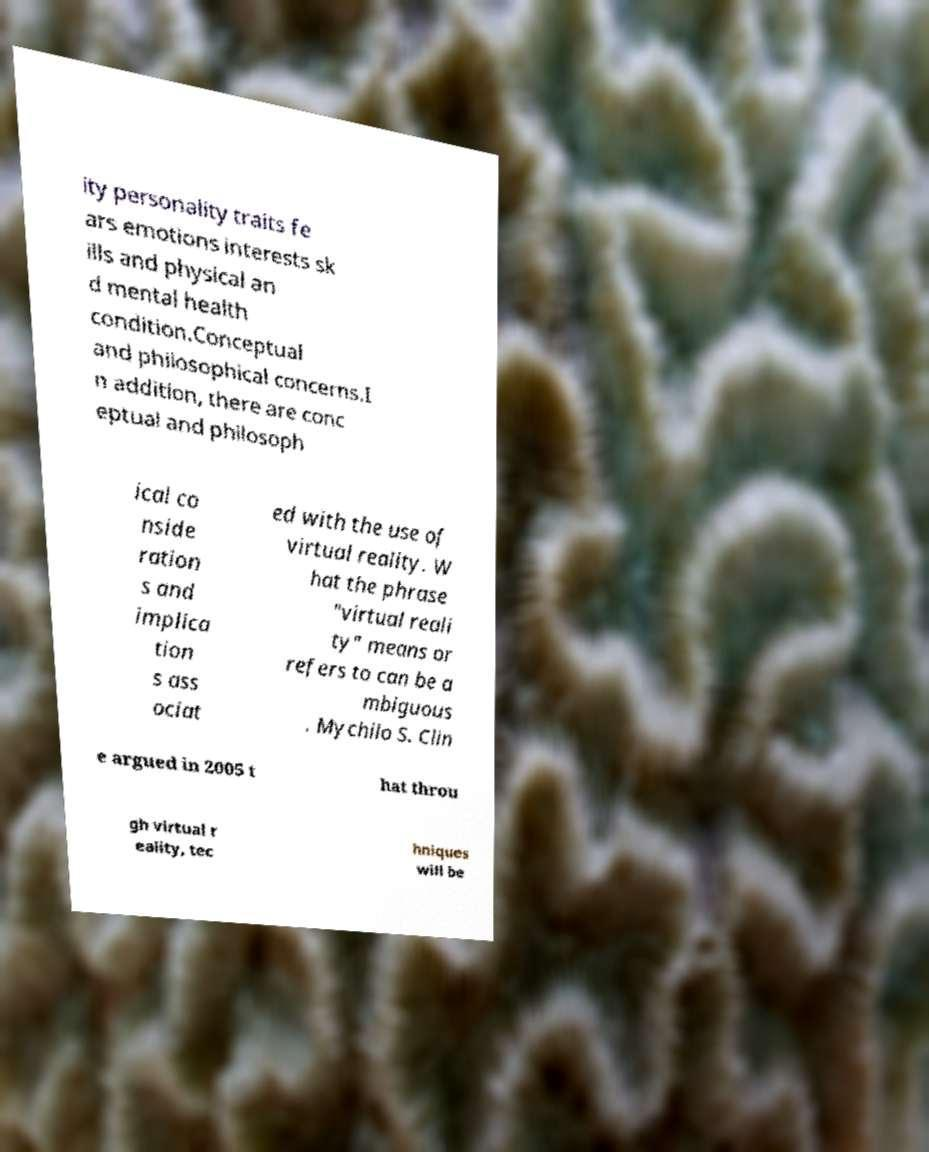For documentation purposes, I need the text within this image transcribed. Could you provide that? ity personality traits fe ars emotions interests sk ills and physical an d mental health condition.Conceptual and philosophical concerns.I n addition, there are conc eptual and philosoph ical co nside ration s and implica tion s ass ociat ed with the use of virtual reality. W hat the phrase "virtual reali ty" means or refers to can be a mbiguous . Mychilo S. Clin e argued in 2005 t hat throu gh virtual r eality, tec hniques will be 